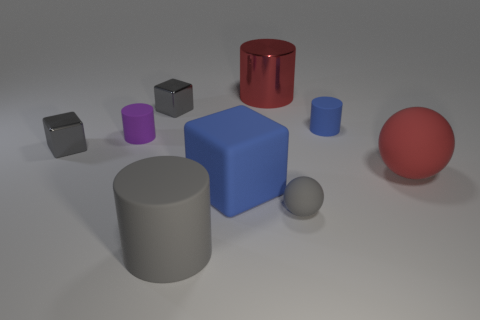Is there anything else that has the same size as the gray rubber cylinder?
Give a very brief answer. Yes. Does the matte block have the same color as the large rubber sphere?
Ensure brevity in your answer.  No. Are there more small cyan shiny objects than gray spheres?
Ensure brevity in your answer.  No. What number of other things are the same color as the large matte block?
Provide a succinct answer. 1. What number of gray cubes are on the left side of the blue block on the left side of the big red metal object?
Your answer should be very brief. 2. Are there any large gray objects on the right side of the blue rubber block?
Your response must be concise. No. There is a small gray object that is right of the big cylinder in front of the tiny blue object; what is its shape?
Keep it short and to the point. Sphere. Are there fewer purple cylinders on the right side of the large red matte ball than small blue matte cylinders that are left of the purple cylinder?
Ensure brevity in your answer.  No. The other big object that is the same shape as the large red metallic object is what color?
Offer a terse response. Gray. What number of gray rubber things are on the left side of the big block and behind the big gray object?
Your answer should be very brief. 0. 